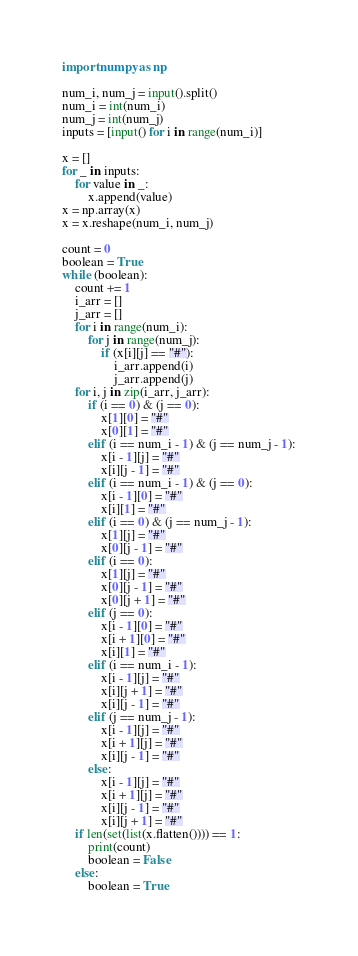<code> <loc_0><loc_0><loc_500><loc_500><_Python_>import numpy as np

num_i, num_j = input().split()
num_i = int(num_i)
num_j = int(num_j)
inputs = [input() for i in range(num_i)]

x = []
for _ in inputs:
    for value in _:
        x.append(value)
x = np.array(x)
x = x.reshape(num_i, num_j)

count = 0
boolean = True
while (boolean):
    count += 1
    i_arr = []
    j_arr = []
    for i in range(num_i):
        for j in range(num_j):
            if (x[i][j] == "#"):
                i_arr.append(i)
                j_arr.append(j)
    for i, j in zip(i_arr, j_arr):
        if (i == 0) & (j == 0):
            x[1][0] = "#"
            x[0][1] = "#"
        elif (i == num_i - 1) & (j == num_j - 1):
            x[i - 1][j] = "#"
            x[i][j - 1] = "#"
        elif (i == num_i - 1) & (j == 0):
            x[i - 1][0] = "#"
            x[i][1] = "#"
        elif (i == 0) & (j == num_j - 1):
            x[1][j] = "#"
            x[0][j - 1] = "#"
        elif (i == 0):
            x[1][j] = "#"
            x[0][j - 1] = "#"
            x[0][j + 1] = "#"
        elif (j == 0):
            x[i - 1][0] = "#"
            x[i + 1][0] = "#"
            x[i][1] = "#"
        elif (i == num_i - 1):
            x[i - 1][j] = "#"
            x[i][j + 1] = "#"
            x[i][j - 1] = "#"
        elif (j == num_j - 1):
            x[i - 1][j] = "#"
            x[i + 1][j] = "#"
            x[i][j - 1] = "#"
        else:
            x[i - 1][j] = "#"
            x[i + 1][j] = "#"
            x[i][j - 1] = "#"
            x[i][j + 1] = "#"
    if len(set(list(x.flatten()))) == 1:
        print(count)
        boolean = False
    else:
        boolean = True</code> 